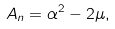Convert formula to latex. <formula><loc_0><loc_0><loc_500><loc_500>A _ { n } = \alpha ^ { 2 } - 2 \mu ,</formula> 